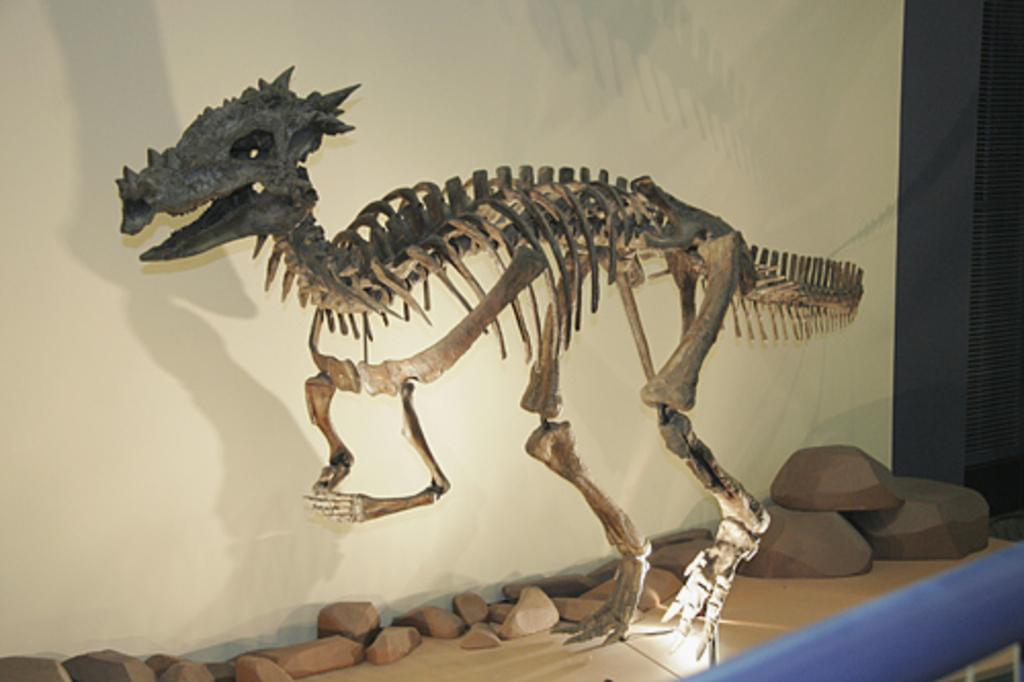What is the main subject in the center of the image? There is a skull of an animal in the center of the image. What can be seen at the bottom of the image? There are rocks at the bottom of the image. What is visible in the background of the image? There is a wall in the background of the image. What type of rhythm is the drum playing in the image? There is no drum or rhythm present in the image; it features a skull and rocks. 